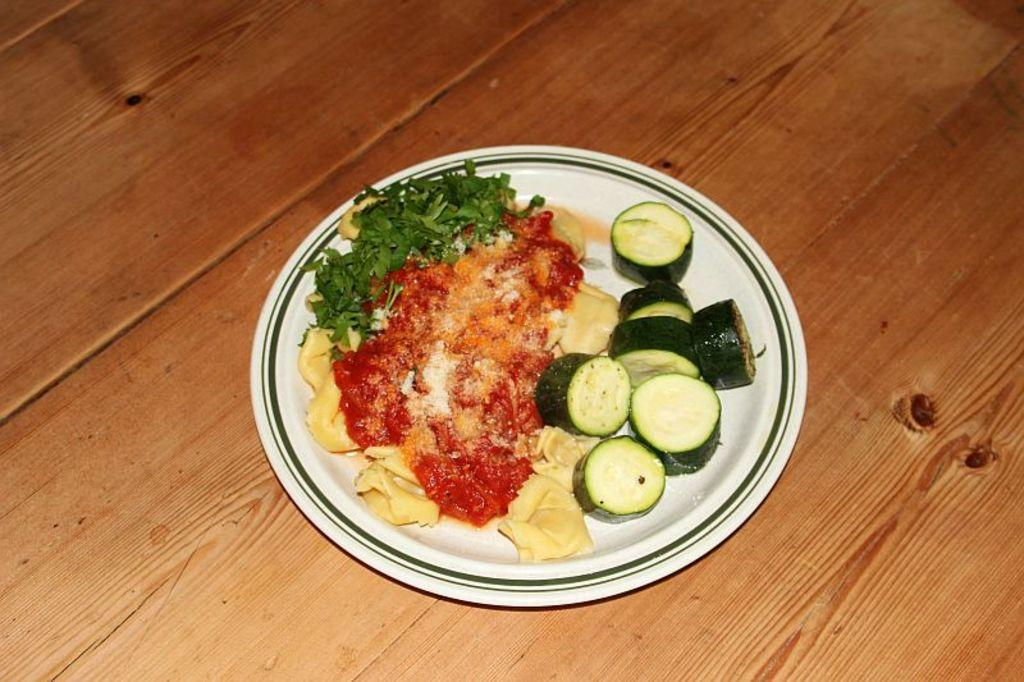What type of table is in the image? The image contains a wooden table. What is placed on the table? There is a plate on the table. What can be found on the plate? There are food items on the plate. How many stamps are on the food items in the image? There are no stamps present on the food items in the image. 